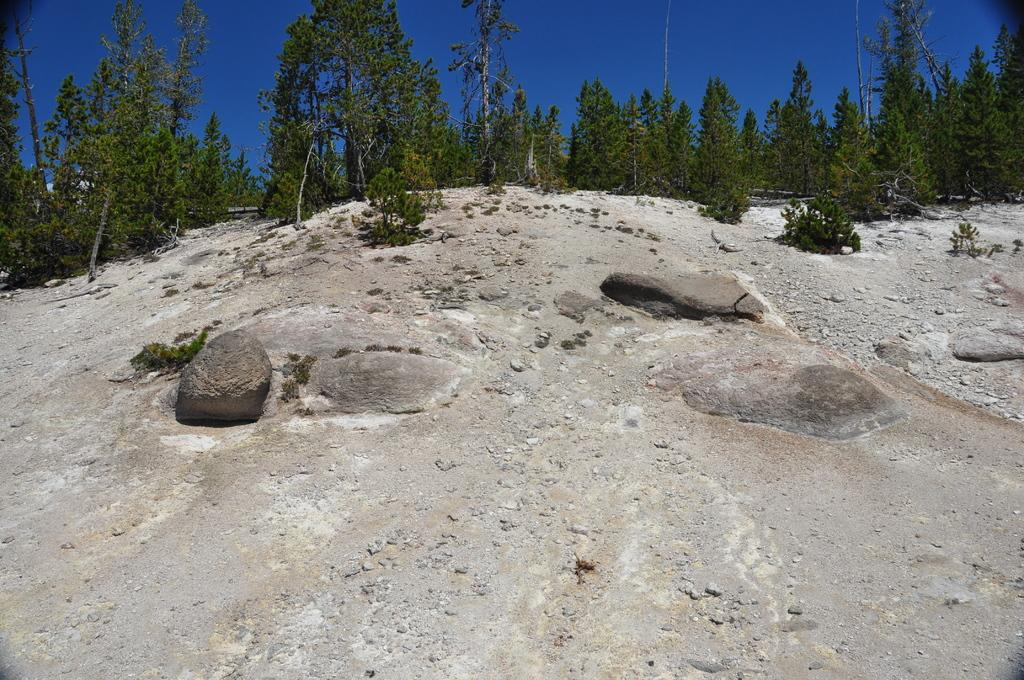What type of natural landscape can be seen in the background of the image? There are many trees in the background of the image. Where are the trees located? The trees are on a hill. What can be seen in the front of the image? There are rocks in the front of the image. What is visible above the hill in the image? The sky is visible above the hill. What type of ink is being used to draw the trees in the image? There is no indication that the trees in the image are drawn or that ink is being used; they are a natural part of the landscape. 